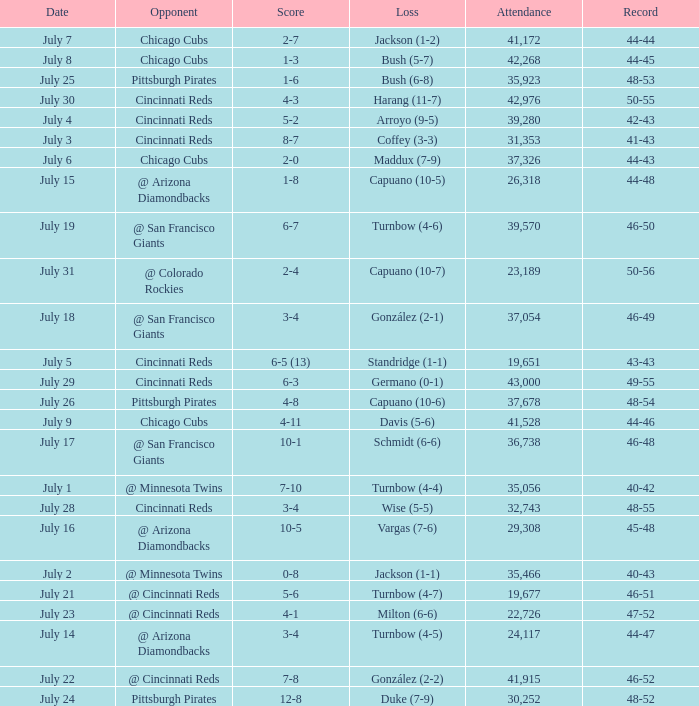What was the loss of the Brewers game when the record was 46-48? Schmidt (6-6). 